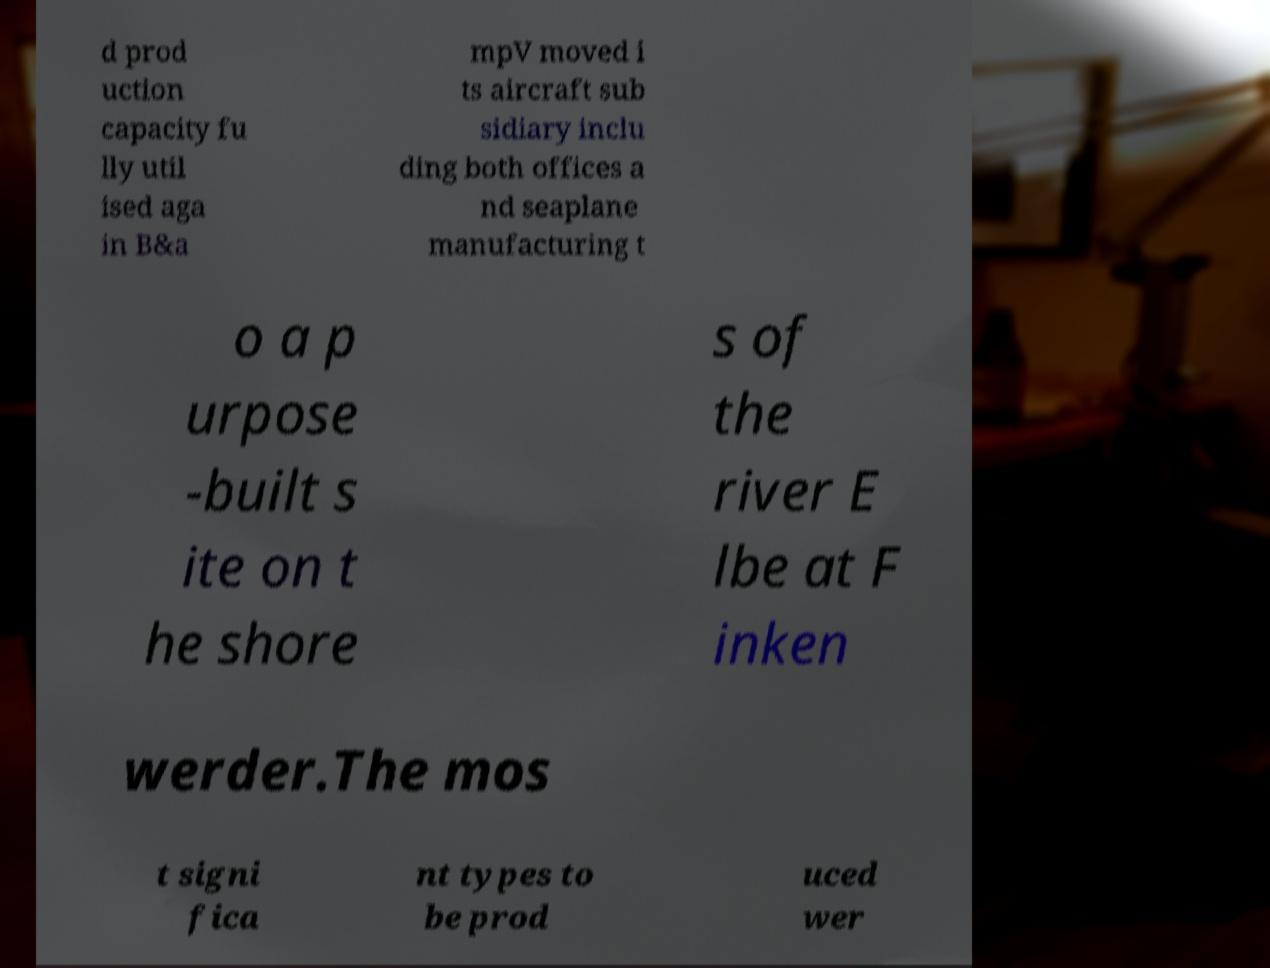Please identify and transcribe the text found in this image. d prod uction capacity fu lly util ised aga in B&a mpV moved i ts aircraft sub sidiary inclu ding both offices a nd seaplane manufacturing t o a p urpose -built s ite on t he shore s of the river E lbe at F inken werder.The mos t signi fica nt types to be prod uced wer 